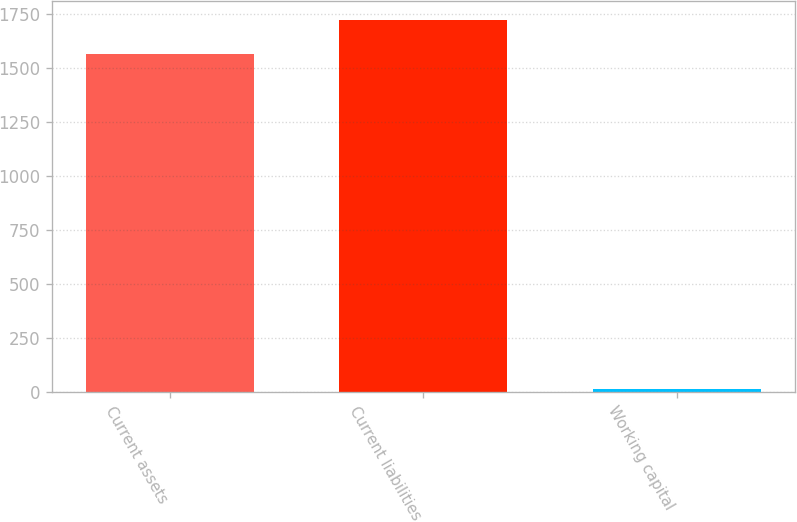Convert chart to OTSL. <chart><loc_0><loc_0><loc_500><loc_500><bar_chart><fcel>Current assets<fcel>Current liabilities<fcel>Working capital<nl><fcel>1563.8<fcel>1720.18<fcel>14.6<nl></chart> 